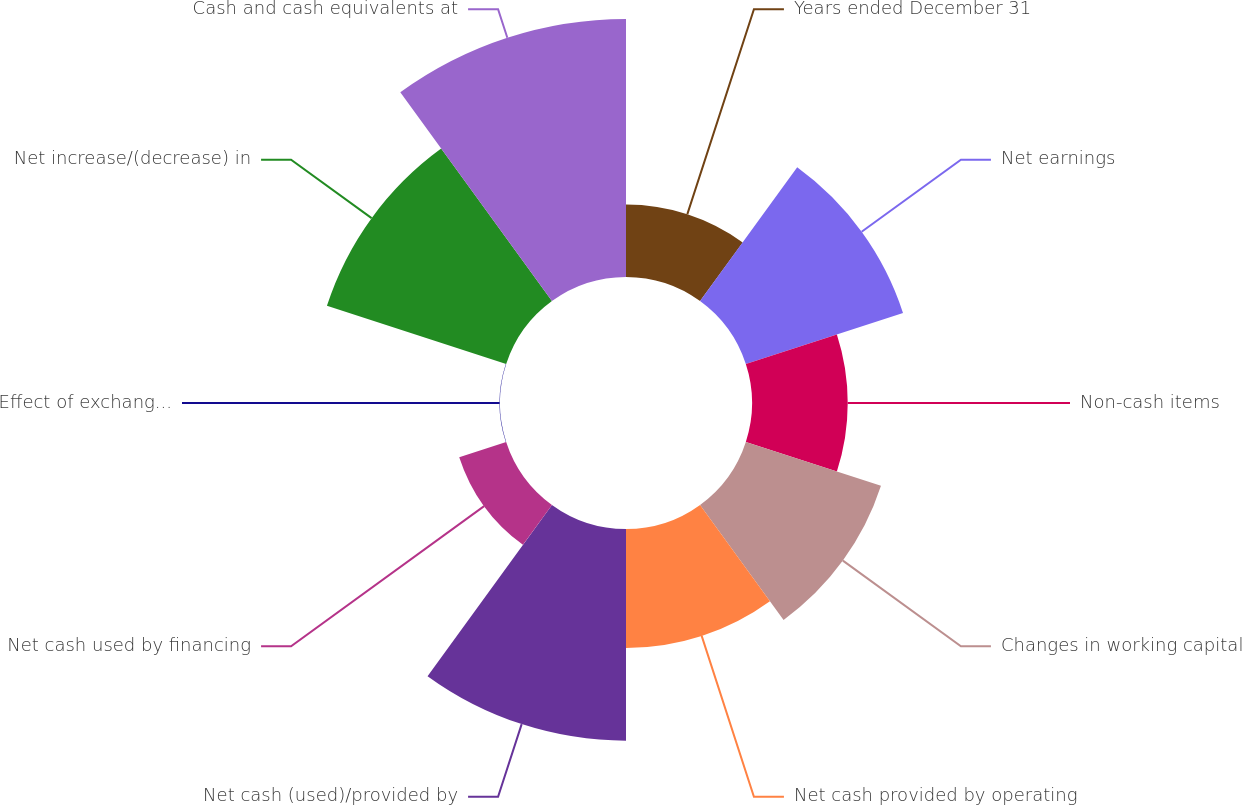Convert chart to OTSL. <chart><loc_0><loc_0><loc_500><loc_500><pie_chart><fcel>Years ended December 31<fcel>Net earnings<fcel>Non-cash items<fcel>Changes in working capital<fcel>Net cash provided by operating<fcel>Net cash (used)/provided by<fcel>Net cash used by financing<fcel>Effect of exchange rate<fcel>Net increase/(decrease) in<fcel>Cash and cash equivalents at<nl><fcel>5.57%<fcel>12.69%<fcel>7.35%<fcel>10.91%<fcel>9.13%<fcel>16.25%<fcel>3.79%<fcel>0.03%<fcel>14.47%<fcel>19.81%<nl></chart> 